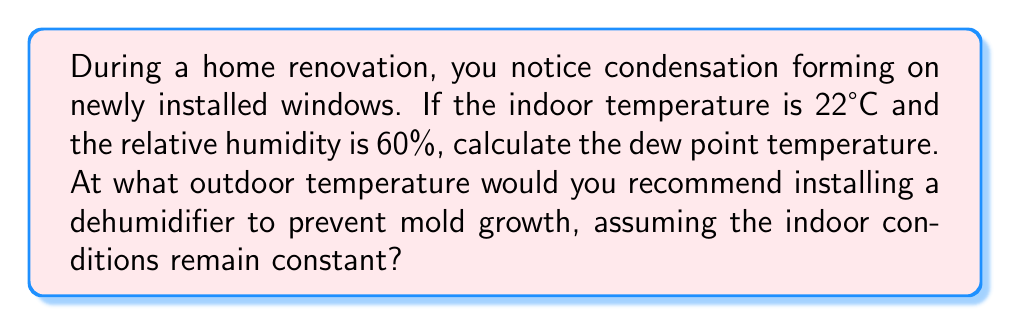Teach me how to tackle this problem. To solve this problem, we'll follow these steps:

1. Calculate the saturation vapor pressure at the indoor temperature.
2. Calculate the actual vapor pressure.
3. Use the vapor pressure to find the dew point temperature.
4. Determine the threshold for dehumidifier installation.

Step 1: Calculate saturation vapor pressure at 22°C
We can use the August-Roche-Magnus approximation:

$$ P_{sat} = 610.94 \times \exp\left(\frac{17.625 \times T}{T + 243.04}\right) $$

Where T is temperature in °C and P_sat is in Pa.

$$ P_{sat} = 610.94 \times \exp\left(\frac{17.625 \times 22}{22 + 243.04}\right) = 2645.45 \text{ Pa} $$

Step 2: Calculate actual vapor pressure
Relative humidity (RH) is the ratio of actual vapor pressure to saturation vapor pressure:

$$ RH = \frac{P_{actual}}{P_{sat}} \times 100\% $$

Rearranging:

$$ P_{actual} = RH \times P_{sat} = 0.60 \times 2645.45 = 1587.27 \text{ Pa} $$

Step 3: Calculate dew point temperature
We can use the inverse of the August-Roche-Magnus equation:

$$ T_{dp} = \frac{243.04 \times \ln(P_{actual}/610.94)}{17.625 - \ln(P_{actual}/610.94)} $$

$$ T_{dp} = \frac{243.04 \times \ln(1587.27/610.94)}{17.625 - \ln(1587.27/610.94)} = 13.85°C $$

Step 4: Determine threshold for dehumidifier installation
To prevent mold growth, it's generally recommended to keep indoor relative humidity below 60%. Since the current indoor conditions are at 60% RH, any drop in temperature below the current indoor temperature (22°C) could lead to condensation and potential mold growth.

To be safe, we should recommend installing a dehumidifier when the outdoor temperature approaches the dew point temperature. A good rule of thumb is to add a 2-3°C buffer to the dew point temperature.

Threshold temperature = Dew point + Buffer = 13.85°C + 2°C ≈ 16°C
Answer: Dew point: 13.85°C. Install dehumidifier when outdoor temperature drops below 16°C. 